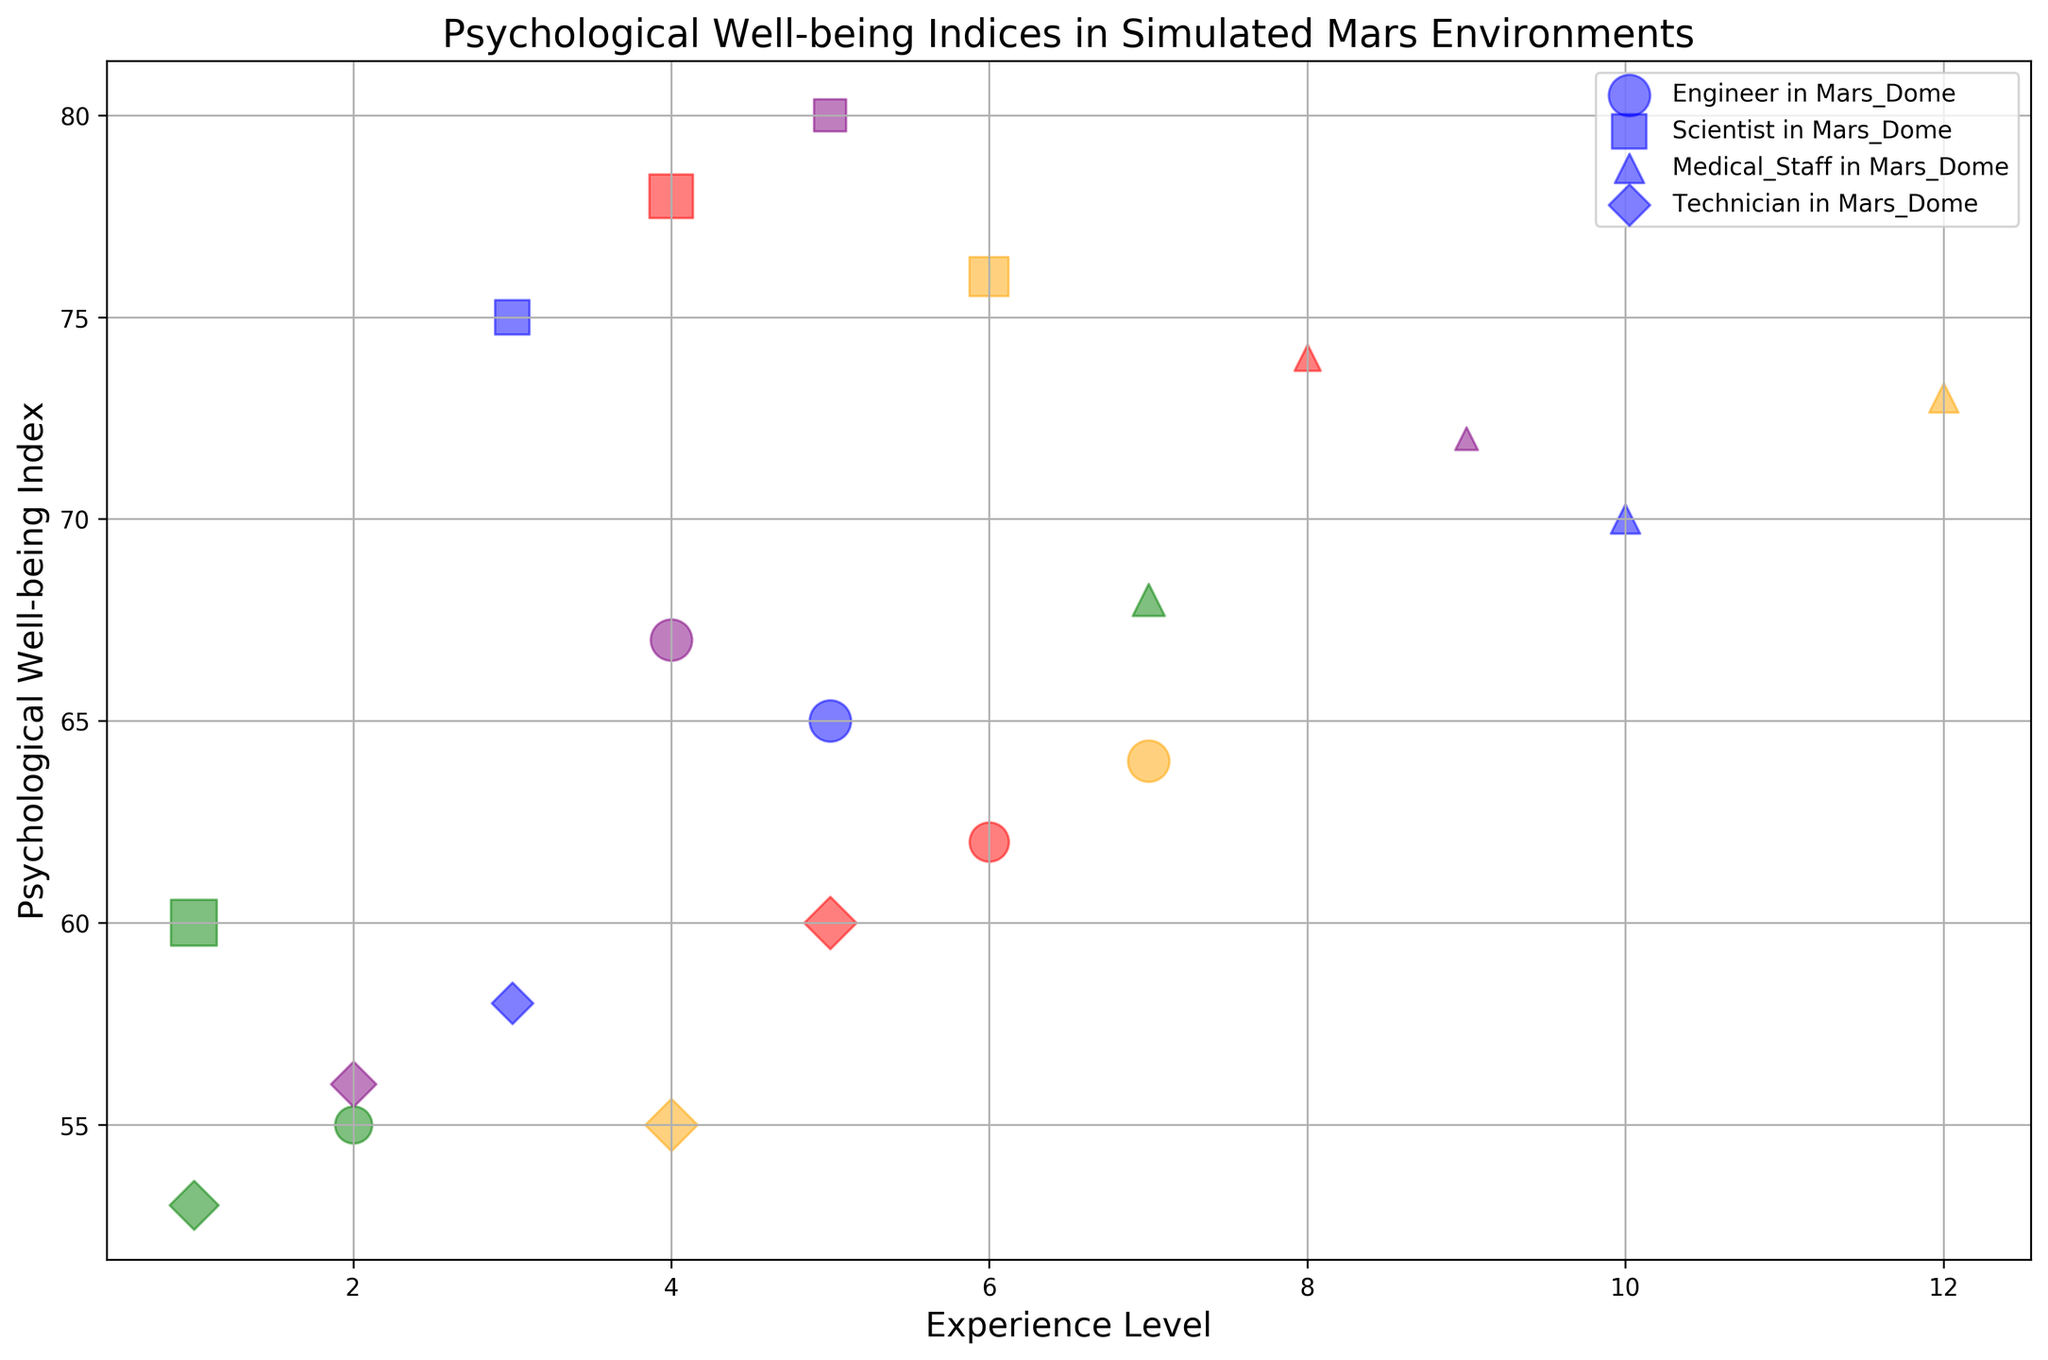Which occupation has the highest psychological well-being index in Mars Outpost? To identify the occupation with the highest well-being index, observe the data points for Mars Outpost. Each data point's y-axis value represents the well-being index. The highest value belongs to "Scientist".
Answer: Scientist How does the psychological well-being index for Engineers compare between Mars Dome and Mars Habitat? Compare the y-axis values of Engineers in Mars Dome and Mars Habitat. Engineers in Mars Dome have a well-being index of 65, while those in Mars Habitat have a lower index of 55.
Answer: Higher in Mars Dome Which environment hosts the occupation with the highest psychological well-being index overall? Look for the highest y-axis value across all environments and occupations. Mars Outpost's "Scientist" occupation has the highest index at 80.
Answer: Mars Outpost What is the average psychological well-being index for Medical Staff across all environments? Examine the y-axis values for Medical Staff in all environments: Mars Dome (70), Mars Habitat (68), Mars Colony (74), Mars Outpost (72), and Mars Shelter (73). Calculate the average: (70+68+74+72+73)/5 = 71.4.
Answer: 71.4 How does the psychological well-being index of Technicians in Mars Dome compare to those in Mars Shelter? Compare the y-axis value: Technicians in Mars Dome have 58, while those in Mars Shelter have 55. Thus, Mars Dome exhibits a slightly higher index.
Answer: Higher in Mars Dome Does the size of the bubble for Engineers in Mars Outpost reflect a larger number of personnel compared to Medical Staff in the same environment? The bubble size correlates with personnel number, scaled by 30. Engineers in Mars Outpost have a larger bubble size than Medical Staff, indicating more personnel.
Answer: Yes Which occupation in Mars Dome shows the lowest psychological well-being index? Identify the minimum y-axis value for Mars Dome. Technicians in Mars Dome have the lowest index at 58.
Answer: Technician Compare the sizes of the bubbles for Engineers and Scientists in Mars Shelter. What does this tell you about the number of personnel in each occupation? Compare the bubble sizes for both Engineers and Scientists in Mars Shelter. Engineers have more personnel since their bubble size is larger.
Answer: Engineers have more personnel Which occupation in Mars Habitat has the highest experience level? Check the x-axis value for Mars Habitat and identify the maximum for the occupations there. "Medical Staff" have the highest experience level at 7.
Answer: Medical Staff What is the range of psychological well-being indices for Scientists across all environments? Find the minimum and maximum y-axis values for Scientists in all environments. The range is from 60 (Mars Habitat) to 80 (Mars Outpost).
Answer: 60 to 80 